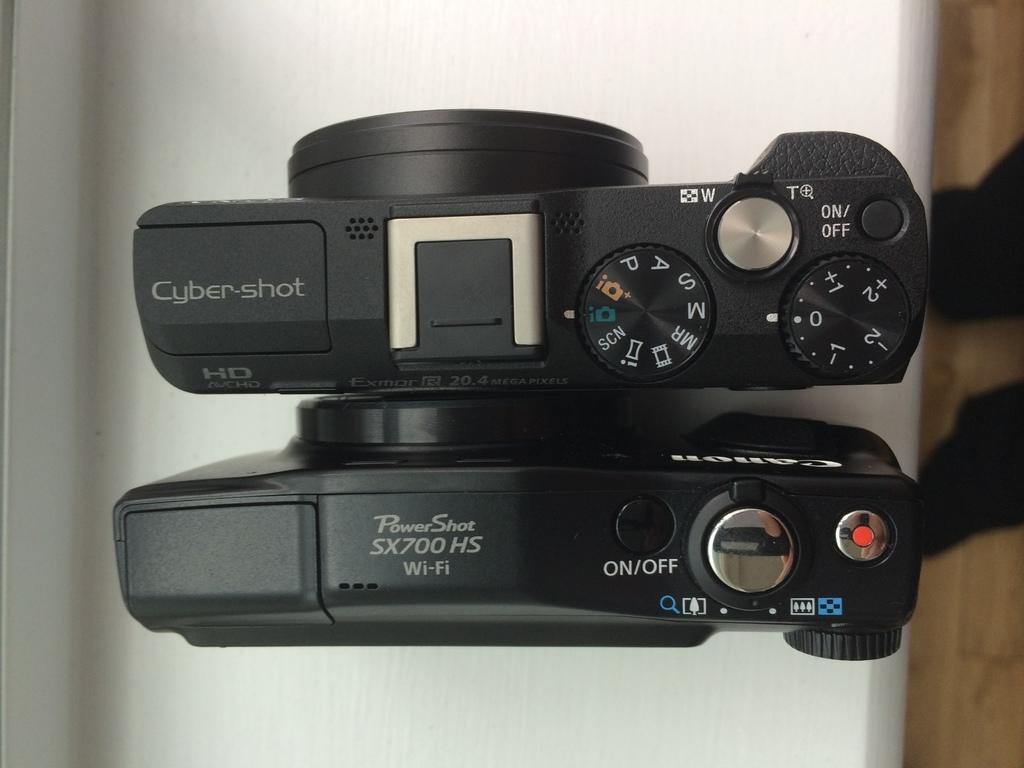<image>
Give a short and clear explanation of the subsequent image. A Poershot X700 camera is seen from above with all its dials and settings. 